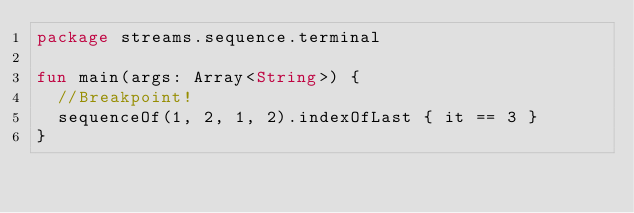<code> <loc_0><loc_0><loc_500><loc_500><_Kotlin_>package streams.sequence.terminal

fun main(args: Array<String>) {
  //Breakpoint!
  sequenceOf(1, 2, 1, 2).indexOfLast { it == 3 }
}</code> 